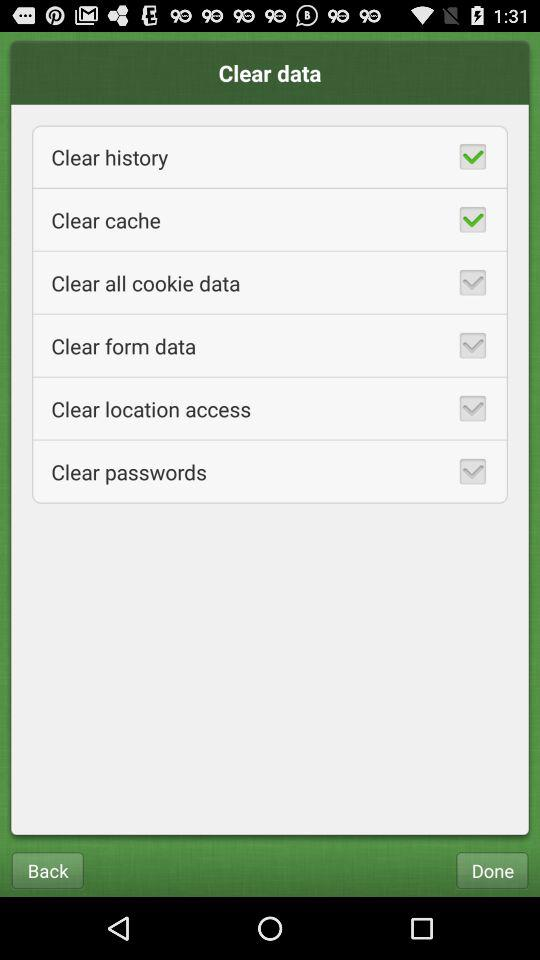What is the current state of clear password? The status is off. 